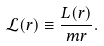Convert formula to latex. <formula><loc_0><loc_0><loc_500><loc_500>\mathcal { L } ( r ) \equiv \frac { L ( r ) } { m r } .</formula> 